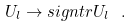<formula> <loc_0><loc_0><loc_500><loc_500>U _ { l } \rightarrow s i g n t r U _ { l } \ .</formula> 